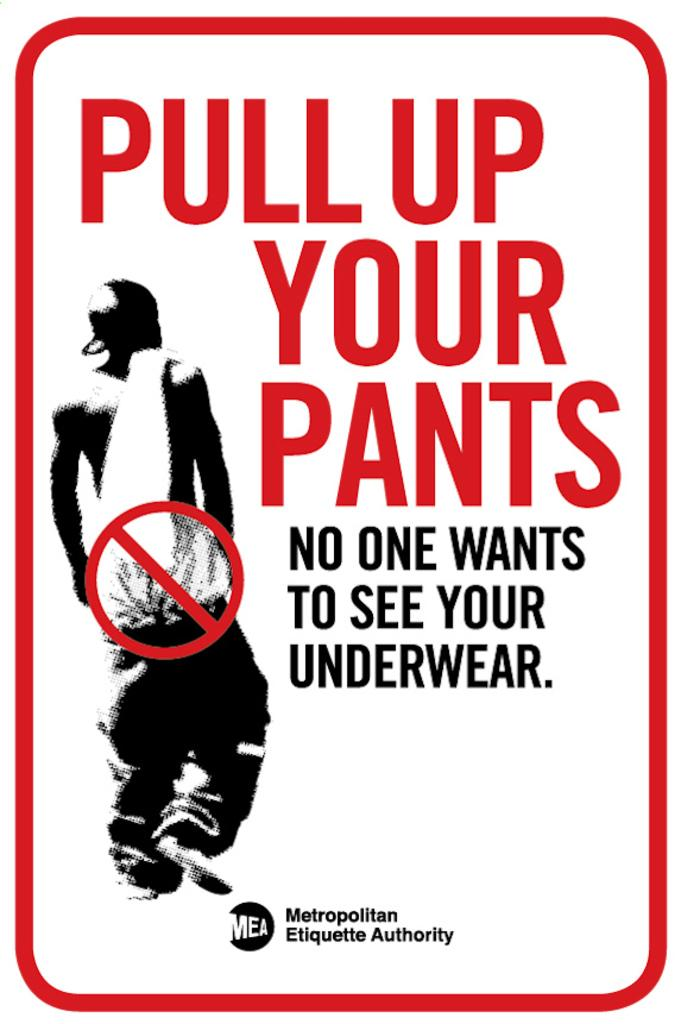<image>
Create a compact narrative representing the image presented. A post for Pull up your pant by Metropolitan Etiquette Authority. 